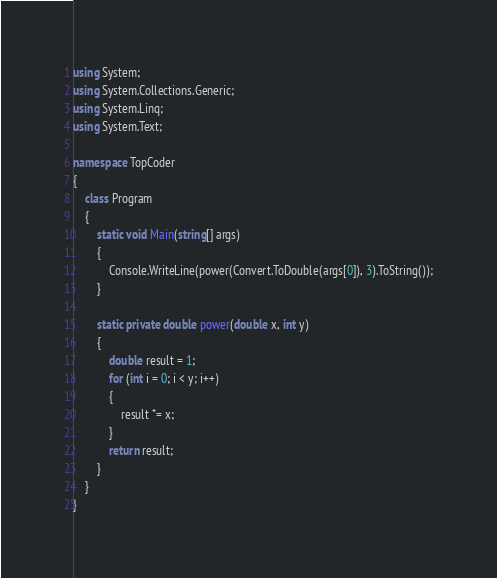<code> <loc_0><loc_0><loc_500><loc_500><_C#_>using System;
using System.Collections.Generic;
using System.Linq;
using System.Text;

namespace TopCoder
{
    class Program
    {
        static void Main(string[] args)
        {
            Console.WriteLine(power(Convert.ToDouble(args[0]), 3).ToString());
        }

        static private double power(double x, int y)
        {
            double result = 1;
            for (int i = 0; i < y; i++)
            {
                result *= x;
            }
            return result;
        }
    }
}</code> 